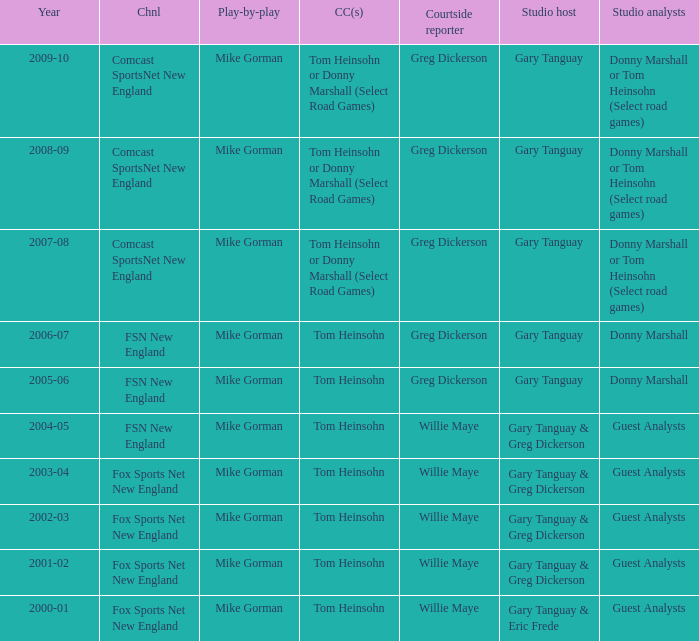WHich Studio analysts has a Studio host of gary tanguay in 2009-10? Donny Marshall or Tom Heinsohn (Select road games). Parse the table in full. {'header': ['Year', 'Chnl', 'Play-by-play', 'CC(s)', 'Courtside reporter', 'Studio host', 'Studio analysts'], 'rows': [['2009-10', 'Comcast SportsNet New England', 'Mike Gorman', 'Tom Heinsohn or Donny Marshall (Select Road Games)', 'Greg Dickerson', 'Gary Tanguay', 'Donny Marshall or Tom Heinsohn (Select road games)'], ['2008-09', 'Comcast SportsNet New England', 'Mike Gorman', 'Tom Heinsohn or Donny Marshall (Select Road Games)', 'Greg Dickerson', 'Gary Tanguay', 'Donny Marshall or Tom Heinsohn (Select road games)'], ['2007-08', 'Comcast SportsNet New England', 'Mike Gorman', 'Tom Heinsohn or Donny Marshall (Select Road Games)', 'Greg Dickerson', 'Gary Tanguay', 'Donny Marshall or Tom Heinsohn (Select road games)'], ['2006-07', 'FSN New England', 'Mike Gorman', 'Tom Heinsohn', 'Greg Dickerson', 'Gary Tanguay', 'Donny Marshall'], ['2005-06', 'FSN New England', 'Mike Gorman', 'Tom Heinsohn', 'Greg Dickerson', 'Gary Tanguay', 'Donny Marshall'], ['2004-05', 'FSN New England', 'Mike Gorman', 'Tom Heinsohn', 'Willie Maye', 'Gary Tanguay & Greg Dickerson', 'Guest Analysts'], ['2003-04', 'Fox Sports Net New England', 'Mike Gorman', 'Tom Heinsohn', 'Willie Maye', 'Gary Tanguay & Greg Dickerson', 'Guest Analysts'], ['2002-03', 'Fox Sports Net New England', 'Mike Gorman', 'Tom Heinsohn', 'Willie Maye', 'Gary Tanguay & Greg Dickerson', 'Guest Analysts'], ['2001-02', 'Fox Sports Net New England', 'Mike Gorman', 'Tom Heinsohn', 'Willie Maye', 'Gary Tanguay & Greg Dickerson', 'Guest Analysts'], ['2000-01', 'Fox Sports Net New England', 'Mike Gorman', 'Tom Heinsohn', 'Willie Maye', 'Gary Tanguay & Eric Frede', 'Guest Analysts']]} 